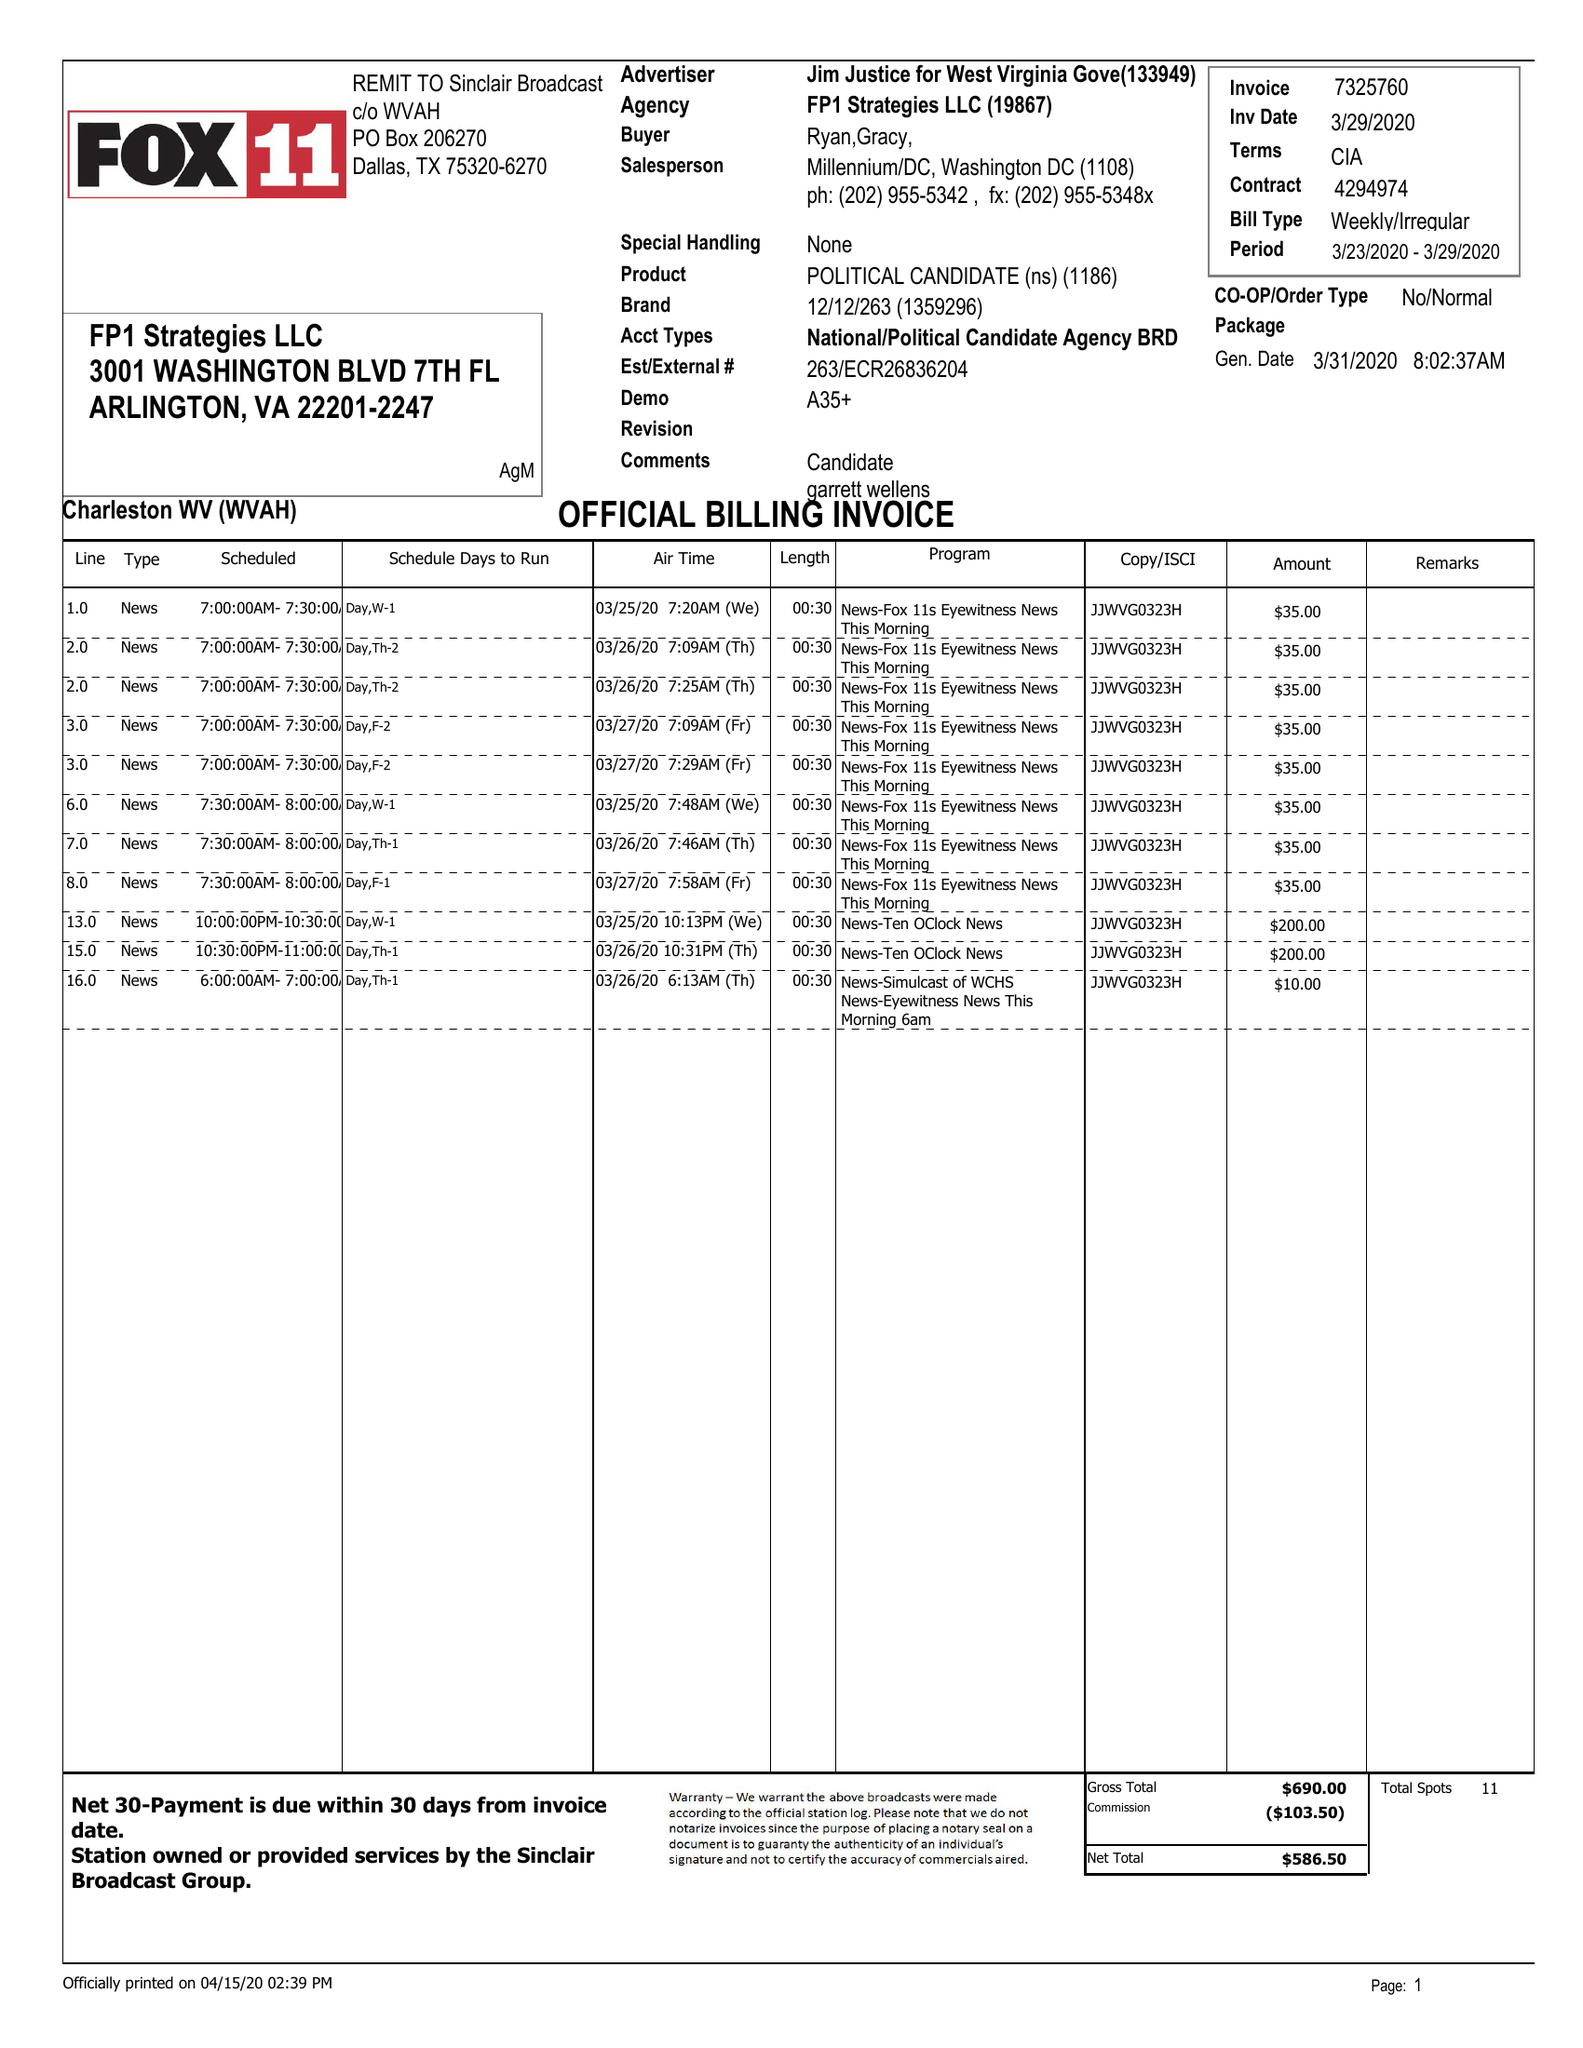What is the value for the flight_to?
Answer the question using a single word or phrase. 03/29/20 